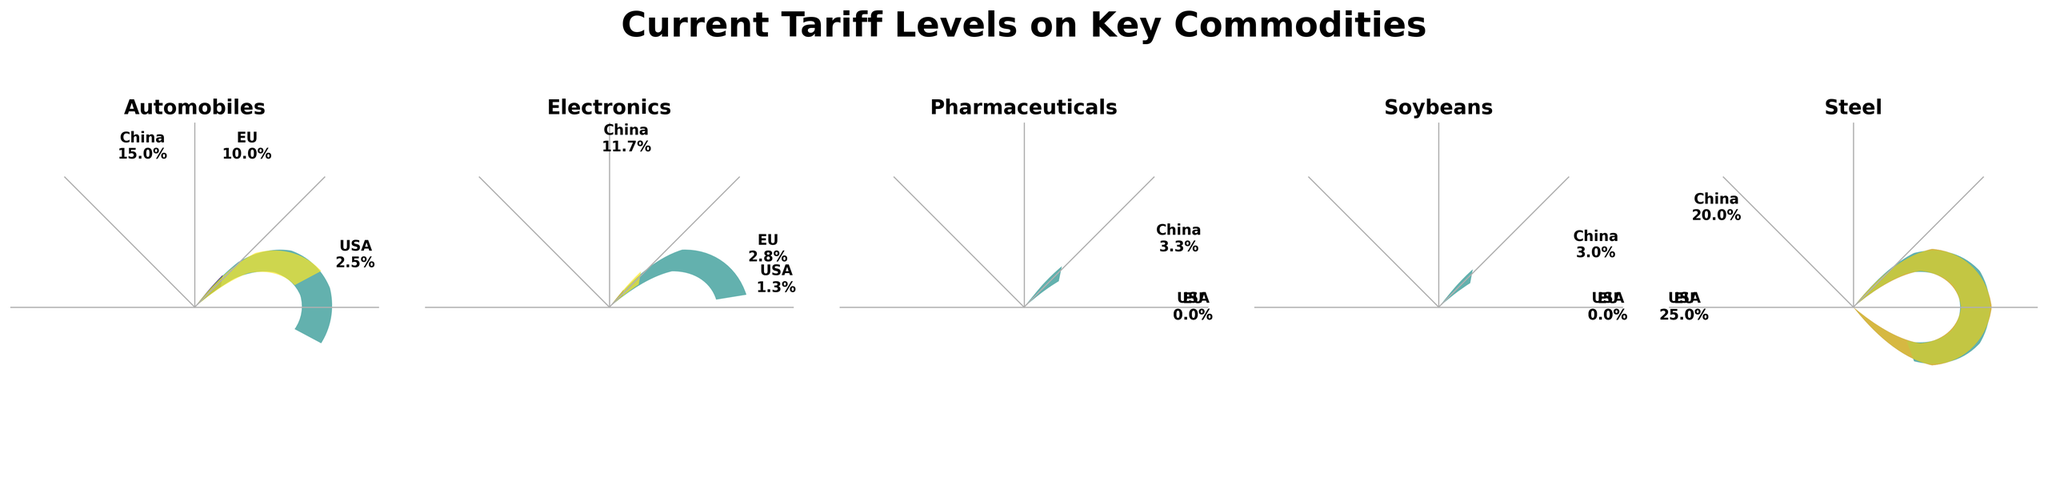What is the title of the chart? The title of the chart is the text displayed prominently at the top of the figure.
Answer: Current Tariff Levels on Key Commodities Which country has the highest tariff rate on electronics? Check the segment labeled "Electronics" and compare the rates, noting the one with the largest angle.
Answer: China What is the range of tariff rates applied to steel by different countries? Look at the "Steel" segment and identify the lowest and highest rates displayed.
Answer: 20-25% Which country imposes a 25% tariff on steel? In the "Steel" segment, find the wedge corresponding to a 25% tariff rate.
Answer: USA and EU How many commodities have a 0% tariff rate by any country? Review each commodity segment and count those where a country’s wedge shows a 0% rate.
Answer: 3 (Soybeans, Pharmaceuticals, Steel by the EU) What is the difference in the tariff rate on automobiles between the USA and China? Identify the tariffs for "Automobiles" for both the USA and China, and calculate the difference (15 - 2.5).
Answer: 12.5% What is the average tariff rate applied by China on all displayed commodities? Sum all of China's tariff rates and divide by the number of commodities: (3+20+15+11.7+3.3)/5.
Answer: 10% Compare the tariff rates on pharmaceuticals and electronics for the EU. Note the tariff rates in the "Pharmaceuticals" and "Electronics" segments for the EU and compare.
Answer: 0% vs 2.8% Which commodity has the most consistent tariff rates across the USA, China, and the EU? Look at the segments and identify the commodity with the least variance in tariff rates.
Answer: Pharmaceuticals What’s the maximum tariff rate applied by any country to any commodity? Identify the largest angle among all segments in the chart.
Answer: 25% 